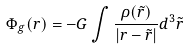Convert formula to latex. <formula><loc_0><loc_0><loc_500><loc_500>\Phi _ { g } ( r ) = - G \int \frac { \rho ( \tilde { r } ) } { | r - \tilde { r } | } d ^ { 3 } \tilde { r }</formula> 